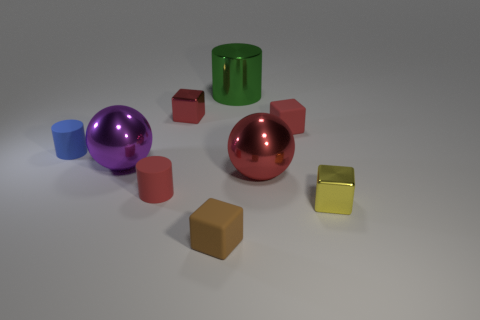Subtract all rubber cylinders. How many cylinders are left? 1 Add 1 red cubes. How many objects exist? 10 Subtract 2 cubes. How many cubes are left? 2 Subtract all red balls. How many balls are left? 1 Subtract all cylinders. How many objects are left? 6 Subtract all yellow cubes. Subtract all blue spheres. How many cubes are left? 3 Subtract all blue balls. How many red blocks are left? 2 Subtract all large green metal things. Subtract all spheres. How many objects are left? 6 Add 5 green cylinders. How many green cylinders are left? 6 Add 3 brown cubes. How many brown cubes exist? 4 